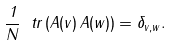Convert formula to latex. <formula><loc_0><loc_0><loc_500><loc_500>\frac { 1 } { N } \ t r \left ( A ( v ) \, A ( w ) \right ) = \delta _ { v , w } .</formula> 